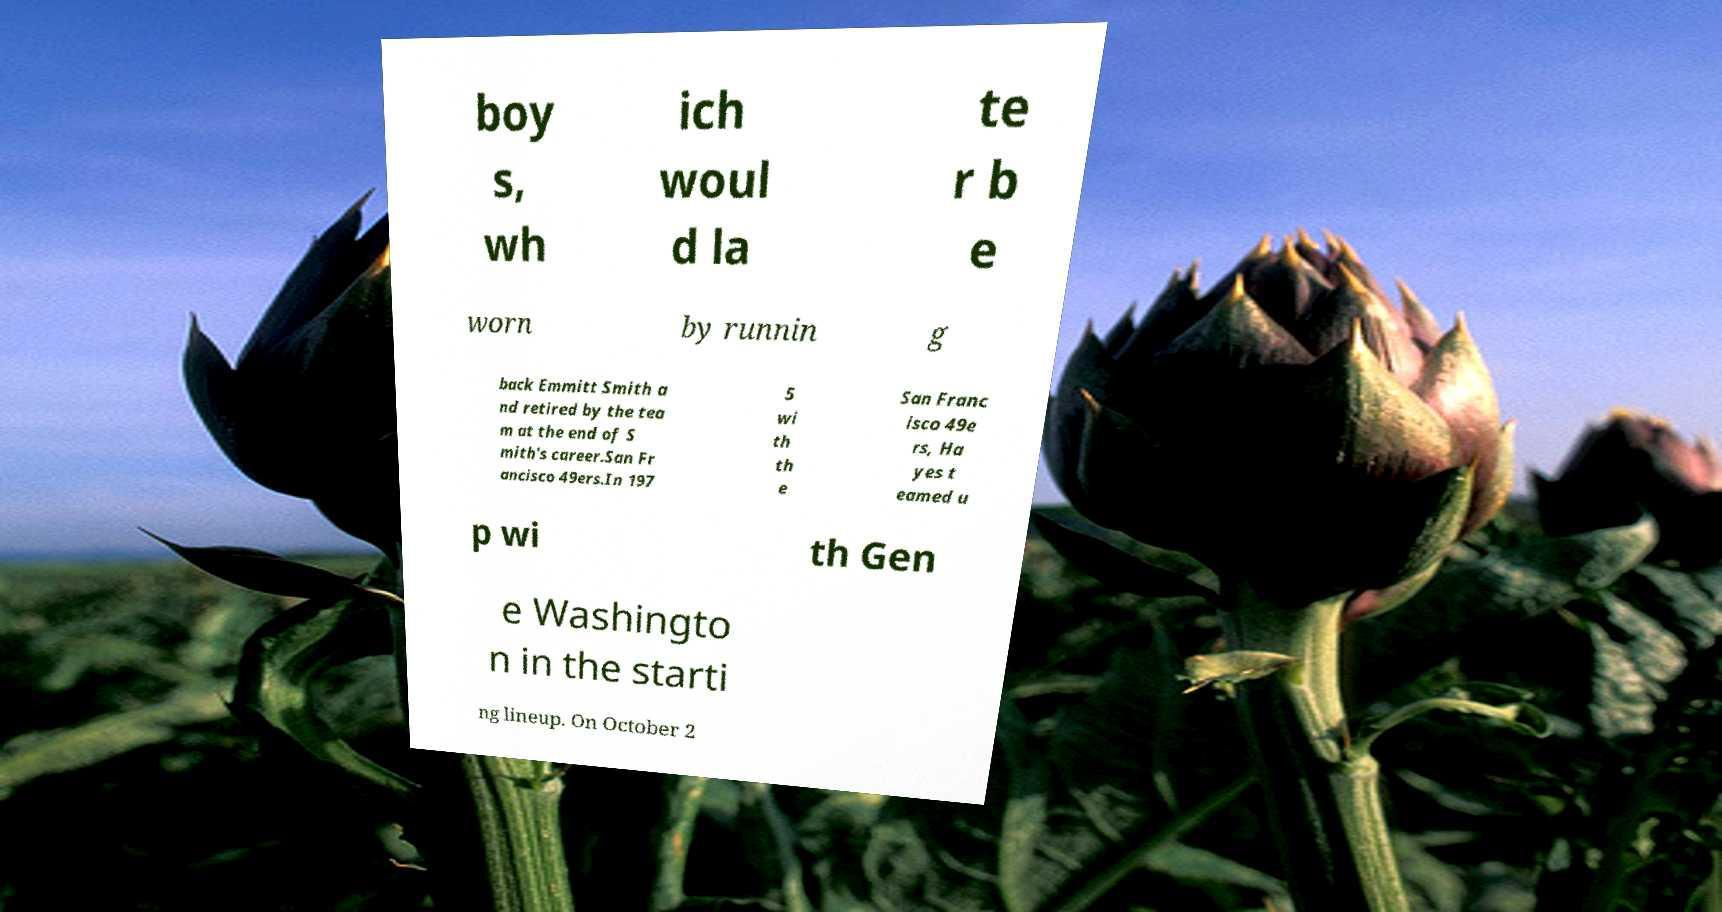For documentation purposes, I need the text within this image transcribed. Could you provide that? boy s, wh ich woul d la te r b e worn by runnin g back Emmitt Smith a nd retired by the tea m at the end of S mith's career.San Fr ancisco 49ers.In 197 5 wi th th e San Franc isco 49e rs, Ha yes t eamed u p wi th Gen e Washingto n in the starti ng lineup. On October 2 